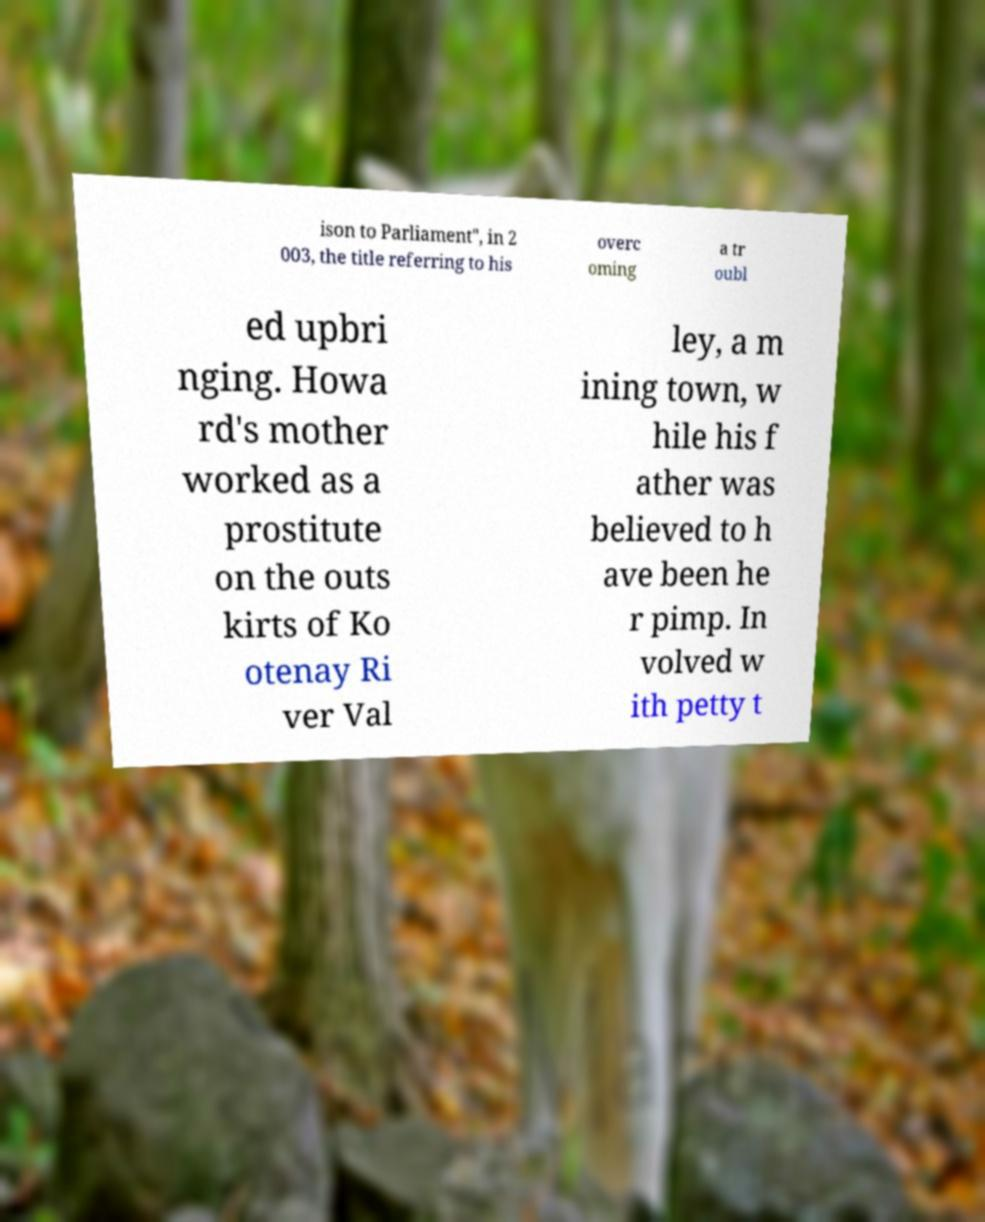Can you accurately transcribe the text from the provided image for me? ison to Parliament", in 2 003, the title referring to his overc oming a tr oubl ed upbri nging. Howa rd's mother worked as a prostitute on the outs kirts of Ko otenay Ri ver Val ley, a m ining town, w hile his f ather was believed to h ave been he r pimp. In volved w ith petty t 